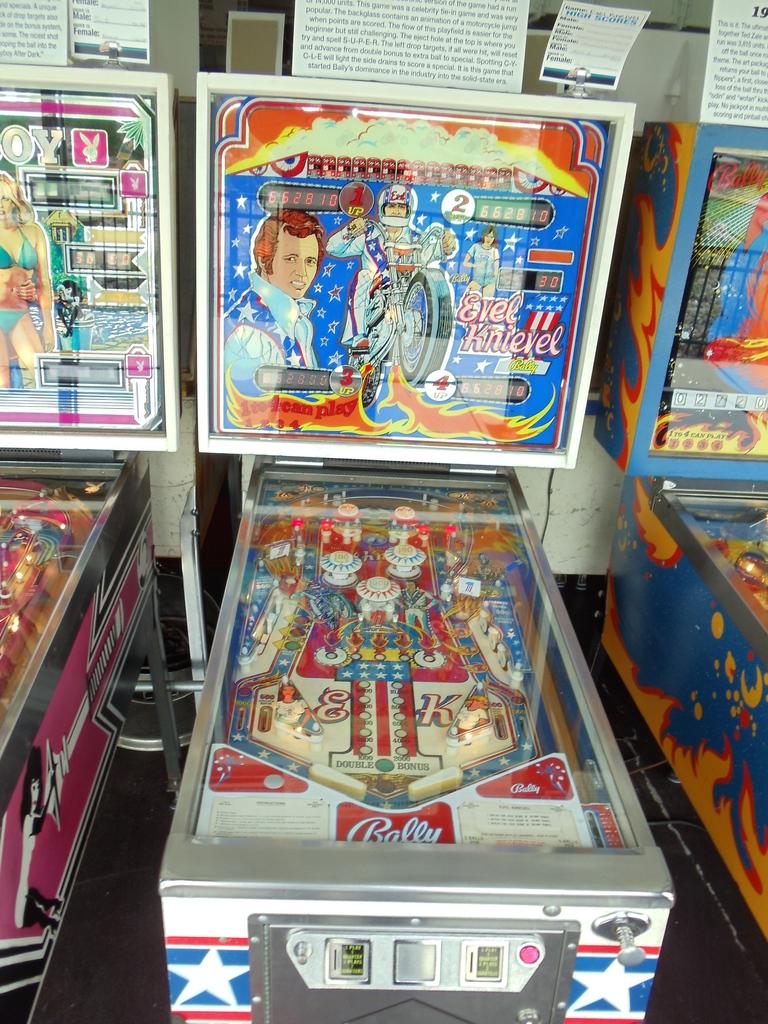What is the theme of the machine?
Provide a succinct answer. Evel knievel. 